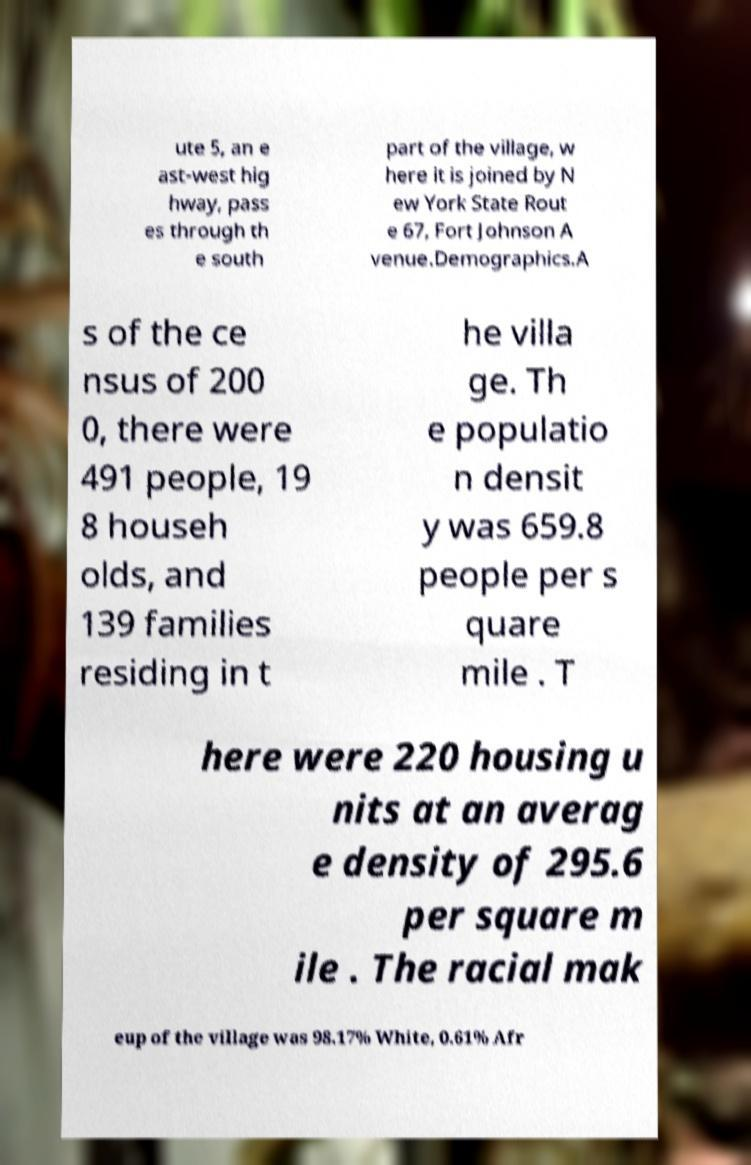There's text embedded in this image that I need extracted. Can you transcribe it verbatim? ute 5, an e ast-west hig hway, pass es through th e south part of the village, w here it is joined by N ew York State Rout e 67, Fort Johnson A venue.Demographics.A s of the ce nsus of 200 0, there were 491 people, 19 8 househ olds, and 139 families residing in t he villa ge. Th e populatio n densit y was 659.8 people per s quare mile . T here were 220 housing u nits at an averag e density of 295.6 per square m ile . The racial mak eup of the village was 98.17% White, 0.61% Afr 